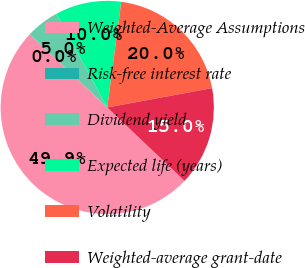Convert chart to OTSL. <chart><loc_0><loc_0><loc_500><loc_500><pie_chart><fcel>Weighted-Average Assumptions<fcel>Risk-free interest rate<fcel>Dividend yield<fcel>Expected life (years)<fcel>Volatility<fcel>Weighted-average grant-date<nl><fcel>49.94%<fcel>0.03%<fcel>5.02%<fcel>10.01%<fcel>19.99%<fcel>15.0%<nl></chart> 